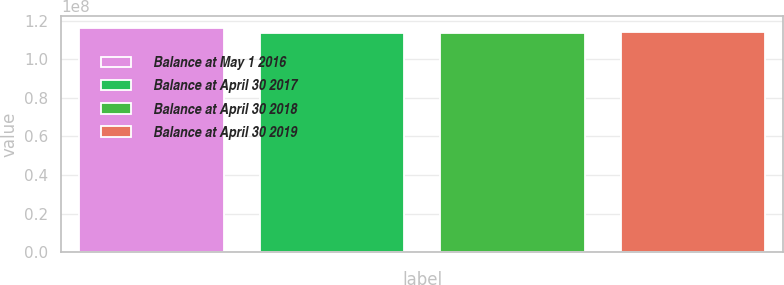<chart> <loc_0><loc_0><loc_500><loc_500><bar_chart><fcel>Balance at May 1 2016<fcel>Balance at April 30 2017<fcel>Balance at April 30 2018<fcel>Balance at April 30 2019<nl><fcel>1.16307e+08<fcel>1.1344e+08<fcel>1.13726e+08<fcel>1.14013e+08<nl></chart> 